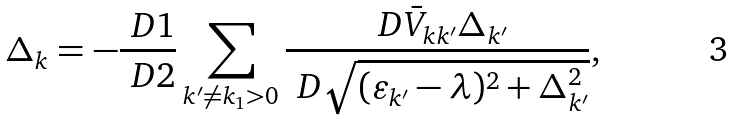Convert formula to latex. <formula><loc_0><loc_0><loc_500><loc_500>\Delta _ { k } = - \frac { \ D 1 } { \ D 2 } \sum _ { k ^ { \prime } \ne k _ { 1 } > 0 } \frac { \ D \bar { V } _ { k k ^ { \prime } } \Delta _ { k ^ { \prime } } } { \ D \sqrt { ( \varepsilon _ { k ^ { \prime } } - \lambda ) ^ { 2 } + \Delta _ { k ^ { \prime } } ^ { 2 } } } ,</formula> 